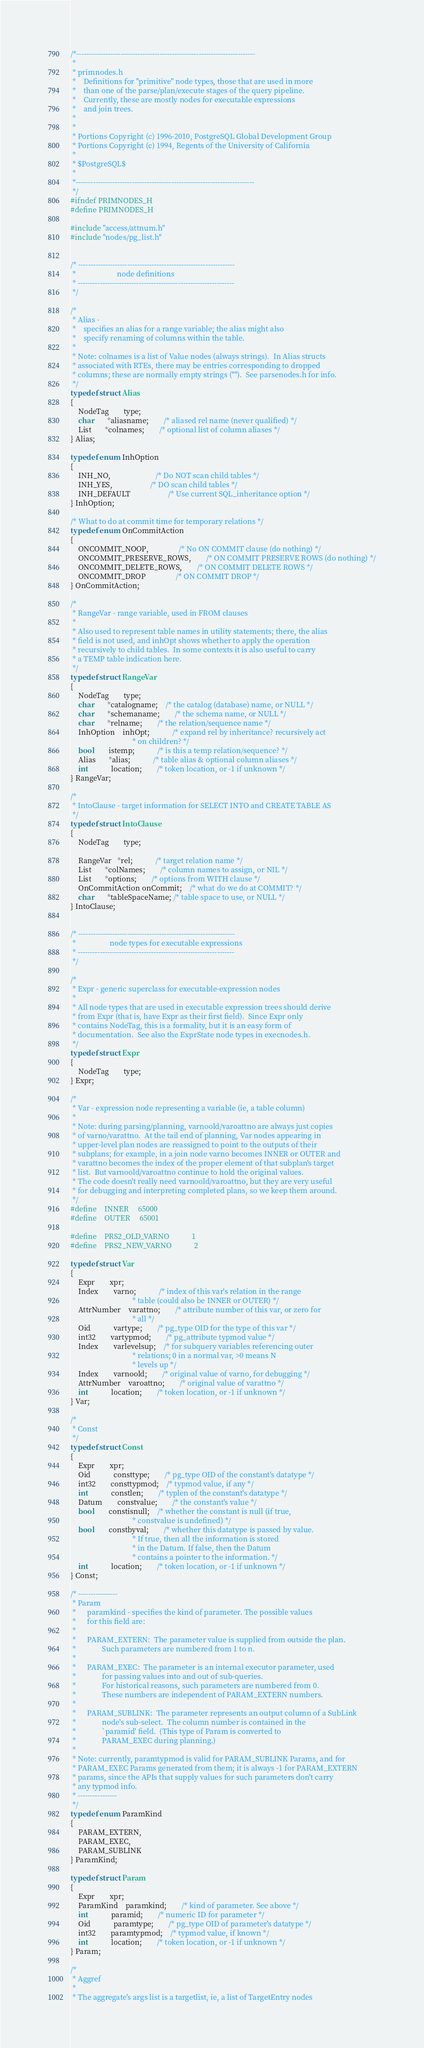<code> <loc_0><loc_0><loc_500><loc_500><_C_>/*-------------------------------------------------------------------------
 *
 * primnodes.h
 *	  Definitions for "primitive" node types, those that are used in more
 *	  than one of the parse/plan/execute stages of the query pipeline.
 *	  Currently, these are mostly nodes for executable expressions
 *	  and join trees.
 *
 *
 * Portions Copyright (c) 1996-2010, PostgreSQL Global Development Group
 * Portions Copyright (c) 1994, Regents of the University of California
 *
 * $PostgreSQL$
 *
 *-------------------------------------------------------------------------
 */
#ifndef PRIMNODES_H
#define PRIMNODES_H

#include "access/attnum.h"
#include "nodes/pg_list.h"


/* ----------------------------------------------------------------
 *						node definitions
 * ----------------------------------------------------------------
 */

/*
 * Alias -
 *	  specifies an alias for a range variable; the alias might also
 *	  specify renaming of columns within the table.
 *
 * Note: colnames is a list of Value nodes (always strings).  In Alias structs
 * associated with RTEs, there may be entries corresponding to dropped
 * columns; these are normally empty strings ("").	See parsenodes.h for info.
 */
typedef struct Alias
{
	NodeTag		type;
	char	   *aliasname;		/* aliased rel name (never qualified) */
	List	   *colnames;		/* optional list of column aliases */
} Alias;

typedef enum InhOption
{
	INH_NO,						/* Do NOT scan child tables */
	INH_YES,					/* DO scan child tables */
	INH_DEFAULT					/* Use current SQL_inheritance option */
} InhOption;

/* What to do at commit time for temporary relations */
typedef enum OnCommitAction
{
	ONCOMMIT_NOOP,				/* No ON COMMIT clause (do nothing) */
	ONCOMMIT_PRESERVE_ROWS,		/* ON COMMIT PRESERVE ROWS (do nothing) */
	ONCOMMIT_DELETE_ROWS,		/* ON COMMIT DELETE ROWS */
	ONCOMMIT_DROP				/* ON COMMIT DROP */
} OnCommitAction;

/*
 * RangeVar - range variable, used in FROM clauses
 *
 * Also used to represent table names in utility statements; there, the alias
 * field is not used, and inhOpt shows whether to apply the operation
 * recursively to child tables.  In some contexts it is also useful to carry
 * a TEMP table indication here.
 */
typedef struct RangeVar
{
	NodeTag		type;
	char	   *catalogname;	/* the catalog (database) name, or NULL */
	char	   *schemaname;		/* the schema name, or NULL */
	char	   *relname;		/* the relation/sequence name */
	InhOption	inhOpt;			/* expand rel by inheritance? recursively act
								 * on children? */
	bool		istemp;			/* is this a temp relation/sequence? */
	Alias	   *alias;			/* table alias & optional column aliases */
	int			location;		/* token location, or -1 if unknown */
} RangeVar;

/*
 * IntoClause - target information for SELECT INTO and CREATE TABLE AS
 */
typedef struct IntoClause
{
	NodeTag		type;

	RangeVar   *rel;			/* target relation name */
	List	   *colNames;		/* column names to assign, or NIL */
	List	   *options;		/* options from WITH clause */
	OnCommitAction onCommit;	/* what do we do at COMMIT? */
	char	   *tableSpaceName; /* table space to use, or NULL */
} IntoClause;


/* ----------------------------------------------------------------
 *					node types for executable expressions
 * ----------------------------------------------------------------
 */

/*
 * Expr - generic superclass for executable-expression nodes
 *
 * All node types that are used in executable expression trees should derive
 * from Expr (that is, have Expr as their first field).  Since Expr only
 * contains NodeTag, this is a formality, but it is an easy form of
 * documentation.  See also the ExprState node types in execnodes.h.
 */
typedef struct Expr
{
	NodeTag		type;
} Expr;

/*
 * Var - expression node representing a variable (ie, a table column)
 *
 * Note: during parsing/planning, varnoold/varoattno are always just copies
 * of varno/varattno.  At the tail end of planning, Var nodes appearing in
 * upper-level plan nodes are reassigned to point to the outputs of their
 * subplans; for example, in a join node varno becomes INNER or OUTER and
 * varattno becomes the index of the proper element of that subplan's target
 * list.  But varnoold/varoattno continue to hold the original values.
 * The code doesn't really need varnoold/varoattno, but they are very useful
 * for debugging and interpreting completed plans, so we keep them around.
 */
#define    INNER		65000
#define    OUTER		65001

#define    PRS2_OLD_VARNO			1
#define    PRS2_NEW_VARNO			2

typedef struct Var
{
	Expr		xpr;
	Index		varno;			/* index of this var's relation in the range
								 * table (could also be INNER or OUTER) */
	AttrNumber	varattno;		/* attribute number of this var, or zero for
								 * all */
	Oid			vartype;		/* pg_type OID for the type of this var */
	int32		vartypmod;		/* pg_attribute typmod value */
	Index		varlevelsup;	/* for subquery variables referencing outer
								 * relations; 0 in a normal var, >0 means N
								 * levels up */
	Index		varnoold;		/* original value of varno, for debugging */
	AttrNumber	varoattno;		/* original value of varattno */
	int			location;		/* token location, or -1 if unknown */
} Var;

/*
 * Const
 */
typedef struct Const
{
	Expr		xpr;
	Oid			consttype;		/* pg_type OID of the constant's datatype */
	int32		consttypmod;	/* typmod value, if any */
	int			constlen;		/* typlen of the constant's datatype */
	Datum		constvalue;		/* the constant's value */
	bool		constisnull;	/* whether the constant is null (if true,
								 * constvalue is undefined) */
	bool		constbyval;		/* whether this datatype is passed by value.
								 * If true, then all the information is stored
								 * in the Datum. If false, then the Datum
								 * contains a pointer to the information. */
	int			location;		/* token location, or -1 if unknown */
} Const;

/* ----------------
 * Param
 *		paramkind - specifies the kind of parameter. The possible values
 *		for this field are:
 *
 *		PARAM_EXTERN:  The parameter value is supplied from outside the plan.
 *				Such parameters are numbered from 1 to n.
 *
 *		PARAM_EXEC:  The parameter is an internal executor parameter, used
 *				for passing values into and out of sub-queries.
 *				For historical reasons, such parameters are numbered from 0.
 *				These numbers are independent of PARAM_EXTERN numbers.
 *
 *		PARAM_SUBLINK:	The parameter represents an output column of a SubLink
 *				node's sub-select.  The column number is contained in the
 *				`paramid' field.  (This type of Param is converted to
 *				PARAM_EXEC during planning.)
 *
 * Note: currently, paramtypmod is valid for PARAM_SUBLINK Params, and for
 * PARAM_EXEC Params generated from them; it is always -1 for PARAM_EXTERN
 * params, since the APIs that supply values for such parameters don't carry
 * any typmod info.
 * ----------------
 */
typedef enum ParamKind
{
	PARAM_EXTERN,
	PARAM_EXEC,
	PARAM_SUBLINK
} ParamKind;

typedef struct Param
{
	Expr		xpr;
	ParamKind	paramkind;		/* kind of parameter. See above */
	int			paramid;		/* numeric ID for parameter */
	Oid			paramtype;		/* pg_type OID of parameter's datatype */
	int32		paramtypmod;	/* typmod value, if known */
	int			location;		/* token location, or -1 if unknown */
} Param;

/*
 * Aggref
 *
 * The aggregate's args list is a targetlist, ie, a list of TargetEntry nodes</code> 